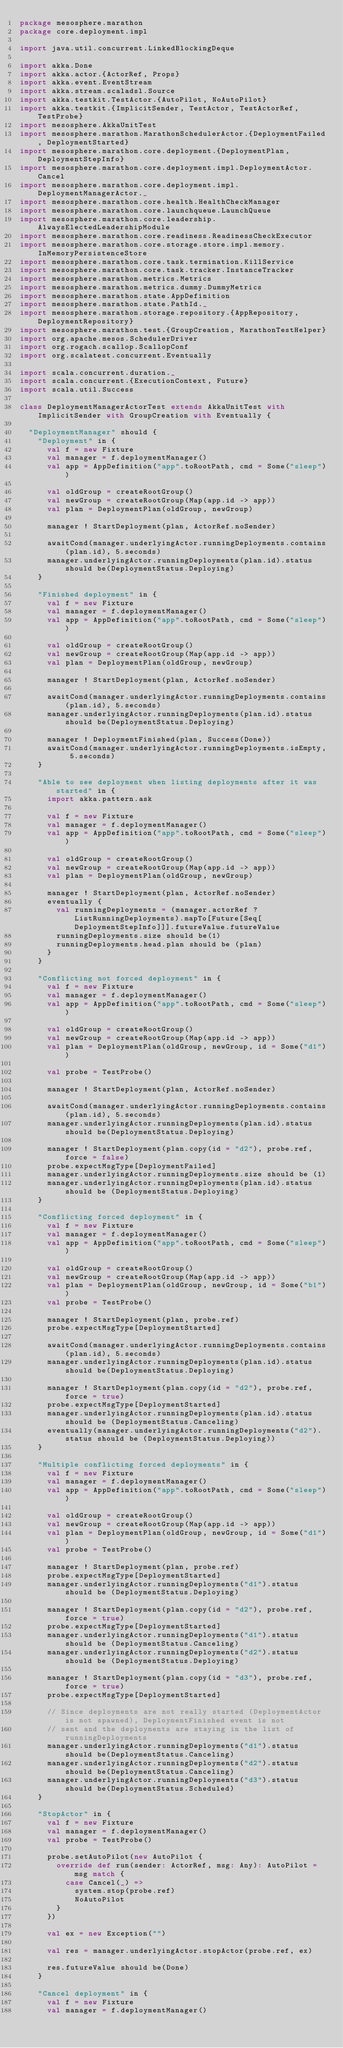Convert code to text. <code><loc_0><loc_0><loc_500><loc_500><_Scala_>package mesosphere.marathon
package core.deployment.impl

import java.util.concurrent.LinkedBlockingDeque

import akka.Done
import akka.actor.{ActorRef, Props}
import akka.event.EventStream
import akka.stream.scaladsl.Source
import akka.testkit.TestActor.{AutoPilot, NoAutoPilot}
import akka.testkit.{ImplicitSender, TestActor, TestActorRef, TestProbe}
import mesosphere.AkkaUnitTest
import mesosphere.marathon.MarathonSchedulerActor.{DeploymentFailed, DeploymentStarted}
import mesosphere.marathon.core.deployment.{DeploymentPlan, DeploymentStepInfo}
import mesosphere.marathon.core.deployment.impl.DeploymentActor.Cancel
import mesosphere.marathon.core.deployment.impl.DeploymentManagerActor._
import mesosphere.marathon.core.health.HealthCheckManager
import mesosphere.marathon.core.launchqueue.LaunchQueue
import mesosphere.marathon.core.leadership.AlwaysElectedLeadershipModule
import mesosphere.marathon.core.readiness.ReadinessCheckExecutor
import mesosphere.marathon.core.storage.store.impl.memory.InMemoryPersistenceStore
import mesosphere.marathon.core.task.termination.KillService
import mesosphere.marathon.core.task.tracker.InstanceTracker
import mesosphere.marathon.metrics.Metrics
import mesosphere.marathon.metrics.dummy.DummyMetrics
import mesosphere.marathon.state.AppDefinition
import mesosphere.marathon.state.PathId._
import mesosphere.marathon.storage.repository.{AppRepository, DeploymentRepository}
import mesosphere.marathon.test.{GroupCreation, MarathonTestHelper}
import org.apache.mesos.SchedulerDriver
import org.rogach.scallop.ScallopConf
import org.scalatest.concurrent.Eventually

import scala.concurrent.duration._
import scala.concurrent.{ExecutionContext, Future}
import scala.util.Success

class DeploymentManagerActorTest extends AkkaUnitTest with ImplicitSender with GroupCreation with Eventually {

  "DeploymentManager" should {
    "Deployment" in {
      val f = new Fixture
      val manager = f.deploymentManager()
      val app = AppDefinition("app".toRootPath, cmd = Some("sleep"))

      val oldGroup = createRootGroup()
      val newGroup = createRootGroup(Map(app.id -> app))
      val plan = DeploymentPlan(oldGroup, newGroup)

      manager ! StartDeployment(plan, ActorRef.noSender)

      awaitCond(manager.underlyingActor.runningDeployments.contains(plan.id), 5.seconds)
      manager.underlyingActor.runningDeployments(plan.id).status should be(DeploymentStatus.Deploying)
    }

    "Finished deployment" in {
      val f = new Fixture
      val manager = f.deploymentManager()
      val app = AppDefinition("app".toRootPath, cmd = Some("sleep"))

      val oldGroup = createRootGroup()
      val newGroup = createRootGroup(Map(app.id -> app))
      val plan = DeploymentPlan(oldGroup, newGroup)

      manager ! StartDeployment(plan, ActorRef.noSender)

      awaitCond(manager.underlyingActor.runningDeployments.contains(plan.id), 5.seconds)
      manager.underlyingActor.runningDeployments(plan.id).status should be(DeploymentStatus.Deploying)

      manager ! DeploymentFinished(plan, Success(Done))
      awaitCond(manager.underlyingActor.runningDeployments.isEmpty, 5.seconds)
    }

    "Able to see deployment when listing deployments after it was started" in {
      import akka.pattern.ask

      val f = new Fixture
      val manager = f.deploymentManager()
      val app = AppDefinition("app".toRootPath, cmd = Some("sleep"))

      val oldGroup = createRootGroup()
      val newGroup = createRootGroup(Map(app.id -> app))
      val plan = DeploymentPlan(oldGroup, newGroup)

      manager ! StartDeployment(plan, ActorRef.noSender)
      eventually {
        val runningDeployments = (manager.actorRef ? ListRunningDeployments).mapTo[Future[Seq[DeploymentStepInfo]]].futureValue.futureValue
        runningDeployments.size should be(1)
        runningDeployments.head.plan should be (plan)
      }
    }

    "Conflicting not forced deployment" in {
      val f = new Fixture
      val manager = f.deploymentManager()
      val app = AppDefinition("app".toRootPath, cmd = Some("sleep"))

      val oldGroup = createRootGroup()
      val newGroup = createRootGroup(Map(app.id -> app))
      val plan = DeploymentPlan(oldGroup, newGroup, id = Some("d1"))

      val probe = TestProbe()

      manager ! StartDeployment(plan, ActorRef.noSender)

      awaitCond(manager.underlyingActor.runningDeployments.contains(plan.id), 5.seconds)
      manager.underlyingActor.runningDeployments(plan.id).status should be(DeploymentStatus.Deploying)

      manager ! StartDeployment(plan.copy(id = "d2"), probe.ref, force = false)
      probe.expectMsgType[DeploymentFailed]
      manager.underlyingActor.runningDeployments.size should be (1)
      manager.underlyingActor.runningDeployments(plan.id).status should be (DeploymentStatus.Deploying)
    }

    "Conflicting forced deployment" in {
      val f = new Fixture
      val manager = f.deploymentManager()
      val app = AppDefinition("app".toRootPath, cmd = Some("sleep"))

      val oldGroup = createRootGroup()
      val newGroup = createRootGroup(Map(app.id -> app))
      val plan = DeploymentPlan(oldGroup, newGroup, id = Some("b1"))
      val probe = TestProbe()

      manager ! StartDeployment(plan, probe.ref)
      probe.expectMsgType[DeploymentStarted]

      awaitCond(manager.underlyingActor.runningDeployments.contains(plan.id), 5.seconds)
      manager.underlyingActor.runningDeployments(plan.id).status should be(DeploymentStatus.Deploying)

      manager ! StartDeployment(plan.copy(id = "d2"), probe.ref, force = true)
      probe.expectMsgType[DeploymentStarted]
      manager.underlyingActor.runningDeployments(plan.id).status should be (DeploymentStatus.Canceling)
      eventually(manager.underlyingActor.runningDeployments("d2").status should be (DeploymentStatus.Deploying))
    }

    "Multiple conflicting forced deployments" in {
      val f = new Fixture
      val manager = f.deploymentManager()
      val app = AppDefinition("app".toRootPath, cmd = Some("sleep"))

      val oldGroup = createRootGroup()
      val newGroup = createRootGroup(Map(app.id -> app))
      val plan = DeploymentPlan(oldGroup, newGroup, id = Some("d1"))
      val probe = TestProbe()

      manager ! StartDeployment(plan, probe.ref)
      probe.expectMsgType[DeploymentStarted]
      manager.underlyingActor.runningDeployments("d1").status should be (DeploymentStatus.Deploying)

      manager ! StartDeployment(plan.copy(id = "d2"), probe.ref, force = true)
      probe.expectMsgType[DeploymentStarted]
      manager.underlyingActor.runningDeployments("d1").status should be (DeploymentStatus.Canceling)
      manager.underlyingActor.runningDeployments("d2").status should be (DeploymentStatus.Deploying)

      manager ! StartDeployment(plan.copy(id = "d3"), probe.ref, force = true)
      probe.expectMsgType[DeploymentStarted]

      // Since deployments are not really started (DeploymentActor is not spawned), DeploymentFinished event is not
      // sent and the deployments are staying in the list of runningDeployments
      manager.underlyingActor.runningDeployments("d1").status should be(DeploymentStatus.Canceling)
      manager.underlyingActor.runningDeployments("d2").status should be(DeploymentStatus.Canceling)
      manager.underlyingActor.runningDeployments("d3").status should be(DeploymentStatus.Scheduled)
    }

    "StopActor" in {
      val f = new Fixture
      val manager = f.deploymentManager()
      val probe = TestProbe()

      probe.setAutoPilot(new AutoPilot {
        override def run(sender: ActorRef, msg: Any): AutoPilot = msg match {
          case Cancel(_) =>
            system.stop(probe.ref)
            NoAutoPilot
        }
      })

      val ex = new Exception("")

      val res = manager.underlyingActor.stopActor(probe.ref, ex)

      res.futureValue should be(Done)
    }

    "Cancel deployment" in {
      val f = new Fixture
      val manager = f.deploymentManager()
</code> 